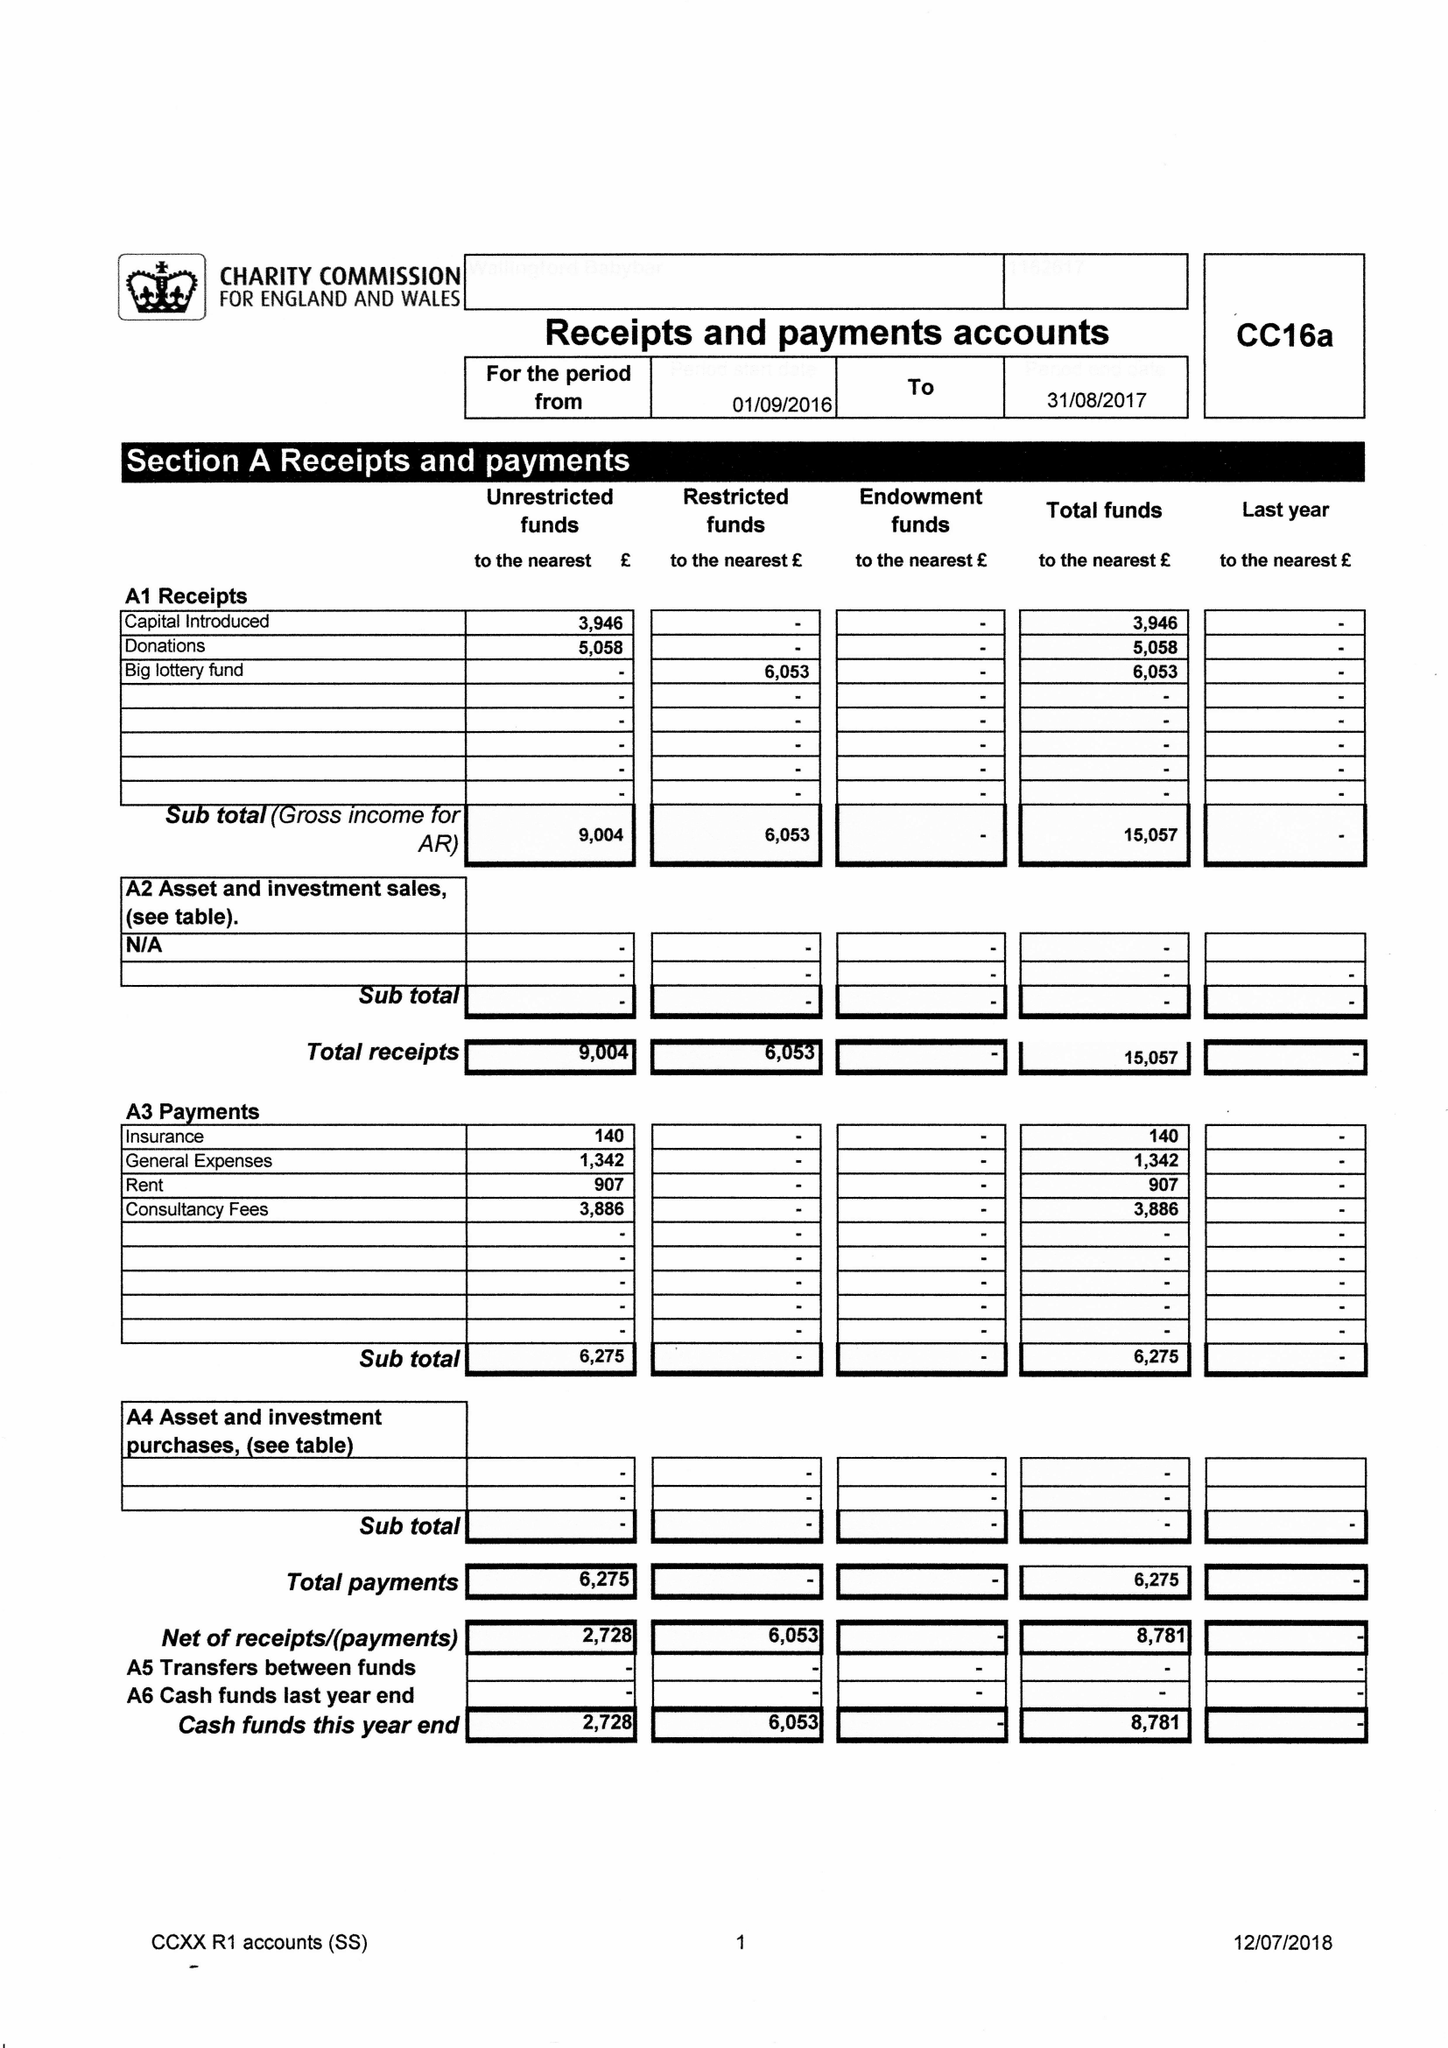What is the value for the income_annually_in_british_pounds?
Answer the question using a single word or phrase. 5088.00 